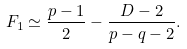Convert formula to latex. <formula><loc_0><loc_0><loc_500><loc_500>F _ { 1 } \simeq \frac { p - 1 } { 2 } - \frac { D - 2 } { p - q - 2 } .</formula> 